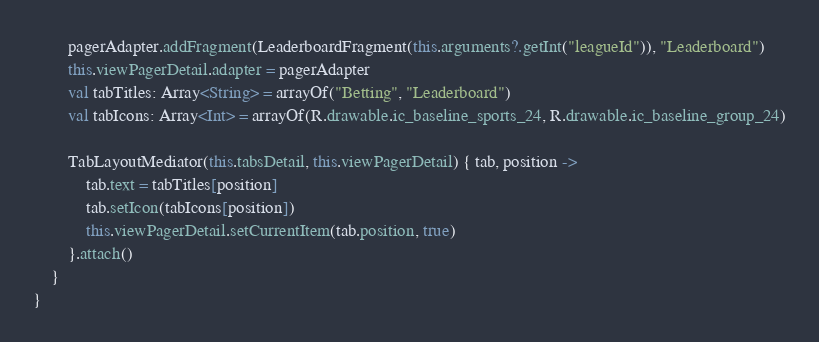Convert code to text. <code><loc_0><loc_0><loc_500><loc_500><_Kotlin_>        pagerAdapter.addFragment(LeaderboardFragment(this.arguments?.getInt("leagueId")), "Leaderboard")
        this.viewPagerDetail.adapter = pagerAdapter
        val tabTitles: Array<String> = arrayOf("Betting", "Leaderboard")
        val tabIcons: Array<Int> = arrayOf(R.drawable.ic_baseline_sports_24, R.drawable.ic_baseline_group_24)

        TabLayoutMediator(this.tabsDetail, this.viewPagerDetail) { tab, position ->
            tab.text = tabTitles[position]
            tab.setIcon(tabIcons[position])
            this.viewPagerDetail.setCurrentItem(tab.position, true)
        }.attach()
    }
}</code> 